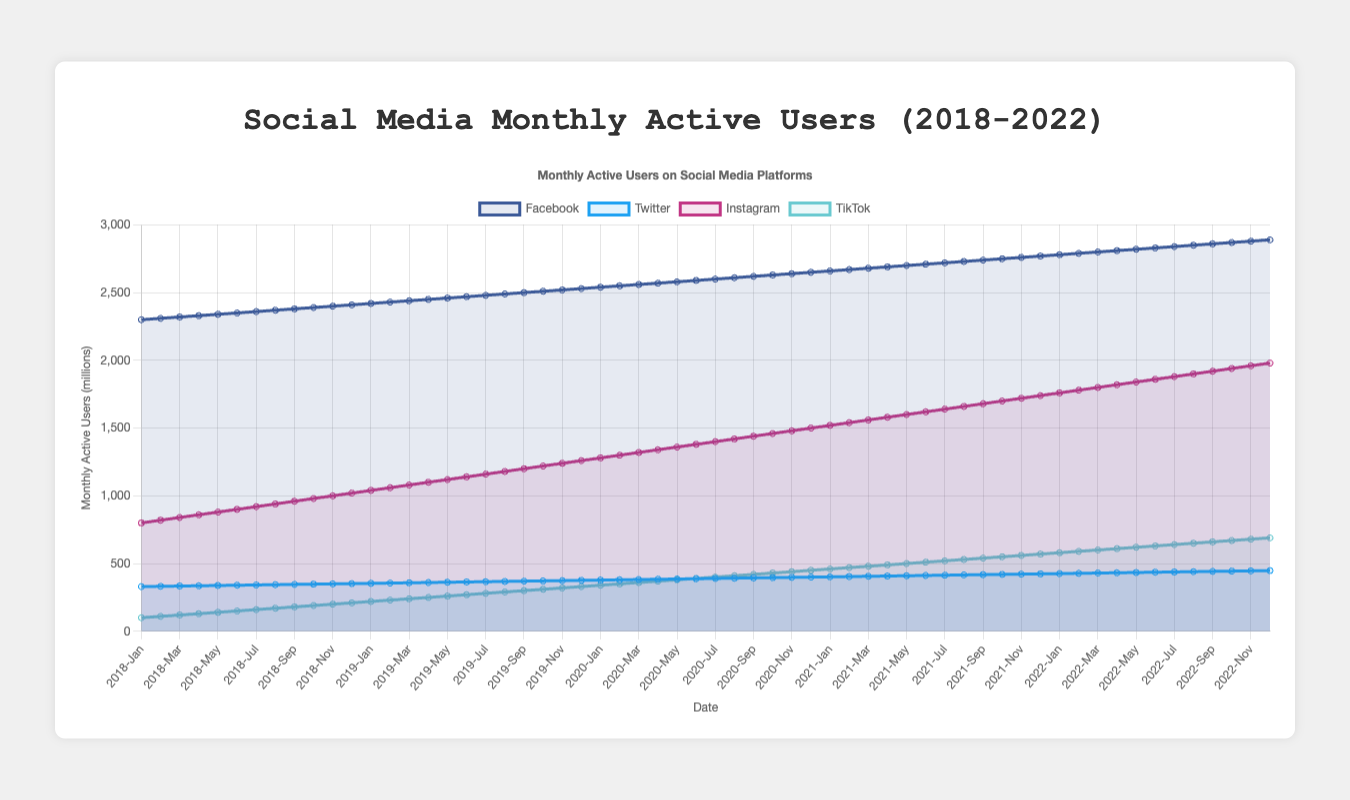What was the total number of monthly active users for Facebook in 2019? To find the total number of monthly active users for Facebook in 2019, sum the monthly values: (2420 + 2430 + 2440 + 2450 + 2460 + 2470 + 2480 + 2490 + 2500 + 2510 + 2520 + 2530) = 29600
Answer: 29600 Between Instagram and TikTok, which platform had a higher growth rate from January 2018 to December 2022? Calculate the growth rate for each platform by finding the difference between the values in January 2018 and December 2022. Instagram: 1980 - 800 = 1180. TikTok: 690 - 100 = 590. Instagram's growth rate is higher than TikTok's.
Answer: Instagram Which platform had the most consistent growth over the past five years, and how can you tell from the visual attributes? The most consistent growth would be represented by the straightest and most smoothly increasing line. Viewing the chart, Facebook shows the most consistent upward slope without any sharp changes, indicating consistent growth.
Answer: Facebook What is the difference in the number of active users between Instagram and Twitter in December 2022? Subtract the number of Twitter users from the number of Instagram users in December 2022. Instagram: 1980, Twitter: 448. So, 1980 - 448 = 1532
Answer: 1532 What year did TikTok surpass 400 million active users, and what is the visual cue? By observing the line for TikTok, it crosses the 400-mark milestone in the year 2020. The visual cue is the point around mid-2020 where the line crosses the 400 horizontal line.
Answer: 2020 Which social media platform had the lowest number of active users in January 2018? Look at the starting point for each platform in January 2018. TikTok is the lowest with 100 million active users.
Answer: TikTok How does the average monthly growth in active users for Twitter compare to Instagram from 2018 to 2022? Calculate the yearly differences for each January, then average across the years. Twitter: [(354-330), (378-354), (402-378), (426-402), (448-426)] -> Average growth (24+24+24+24+22)/5 = 23.6. Instagram: [(1040-800), (1280-1040), (1520-1280), (1760-1520), (1980-1760)] -> Average growth (240+240+240+240+220)/5 = 236. Twitter's average monthly growth is significantly lower.
Answer: Twitter has lower average growth During which year did Facebook grow to have 2500 million monthly active users? Identify when Facebook first reached a monthly active user count of 2500 million. It reached 2500 in September 2019 as per the graph.
Answer: 2019 How many more active users did Facebook have compared to TikTok in December 2022? Subtract the number of TikTok users from the number of Facebook users in December 2022. Facebook: 2890, TikTok: 690. So, 2890 - 690 = 2200
Answer: 2200 When did Instagram reach 1500 million active users, and what is the relevant visual indicator on the plot? By observing the graph for Instagram, it reaches the 1500 million active users mark in December 2020. The relevant visual indicator is the point where the line crosses the 1500 horizontal line, which is at the end of 2020.
Answer: December 2020 